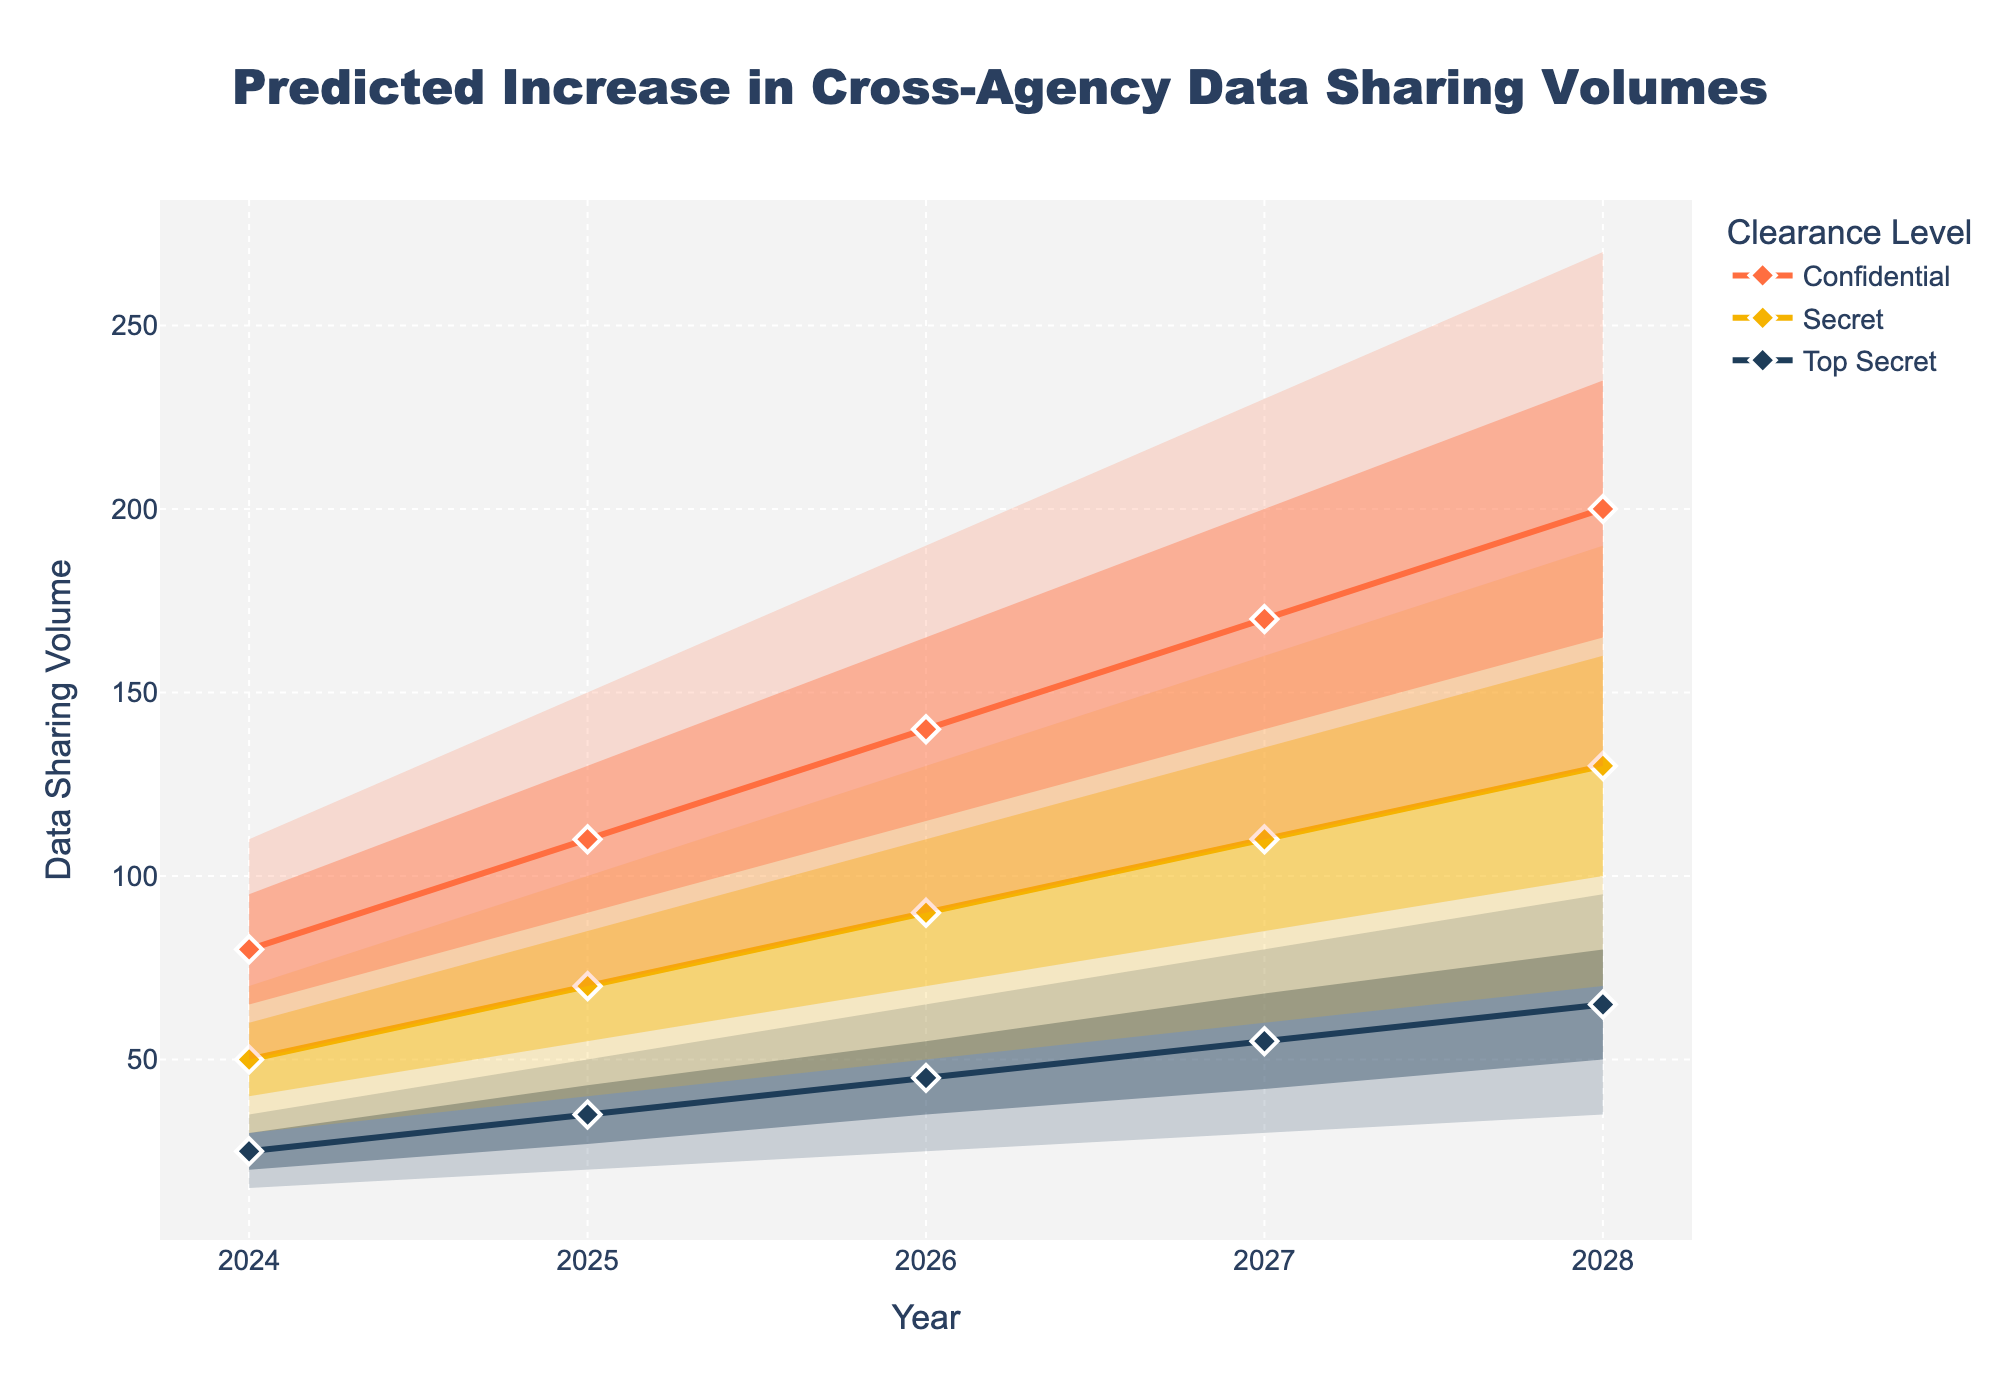What is the title of the figure? The title is located at the top center of the chart and provides a summary of what the figure represents.
Answer: Predicted Increase in Cross-Agency Data Sharing Volumes How many different clearance levels are shown in the chart? The chart legend lists the different clearance levels shown in the figure.
Answer: 3 What are the years covered in the dataset? Check the x-axis labels and the data points extending across the x-axis to identify the range of years covered.
Answer: 2024 to 2028 Which clearance level has the highest predicted data sharing volume in 2028? Compare the predicted values for 2028 across the different clearance levels.
Answer: Confidential By how much does the Mid Estimate for 'Secret' clearance level increase from 2024 to 2028? Compare the Mid Estimate values for 'Secret' in 2024 and 2028 and calculate the difference. 50 (2024) vs. 130 (2028), so 130 - 50 = 80
Answer: 80 What is the range of estimated data sharing volume for 'Top Secret' in 2027? Look at the Low Estimate and High Estimate for 'Top Secret' in 2027. The range is between 30 and 80.
Answer: 30 to 80 Which year shows the highest level of uncertainty for 'Confidential' clearance? Compare the uncertainty ranges for 'Confidential' clearance across the years by looking at the width between Low Estimate and High Estimate.
Answer: 2028 What is the average of the Mid Estimates for 'Top Secret' between 2024 and 2028? Sum the Mid Estimates for each year and divide by the number of years: (25 + 35 + 45 + 55 + 65) / 5 = 45
Answer: 45 How does the data sharing volume for 'Secret' clearance in 2025 compare to 'Top Secret' clearance in 2026 at the Mid Estimate level? Look at the chart to compare the Mid Estimate values for 'Secret' in 2025 (70) and 'Top Secret' in 2026 (45).
Answer: Greater in 2025 What is the spread of estimates for 'Confidential' in 2026? Identify and subtract the Low Estimate from the High Estimate for 'Confidential' in 2026. The spread is 190 - 90 = 100.
Answer: 100 